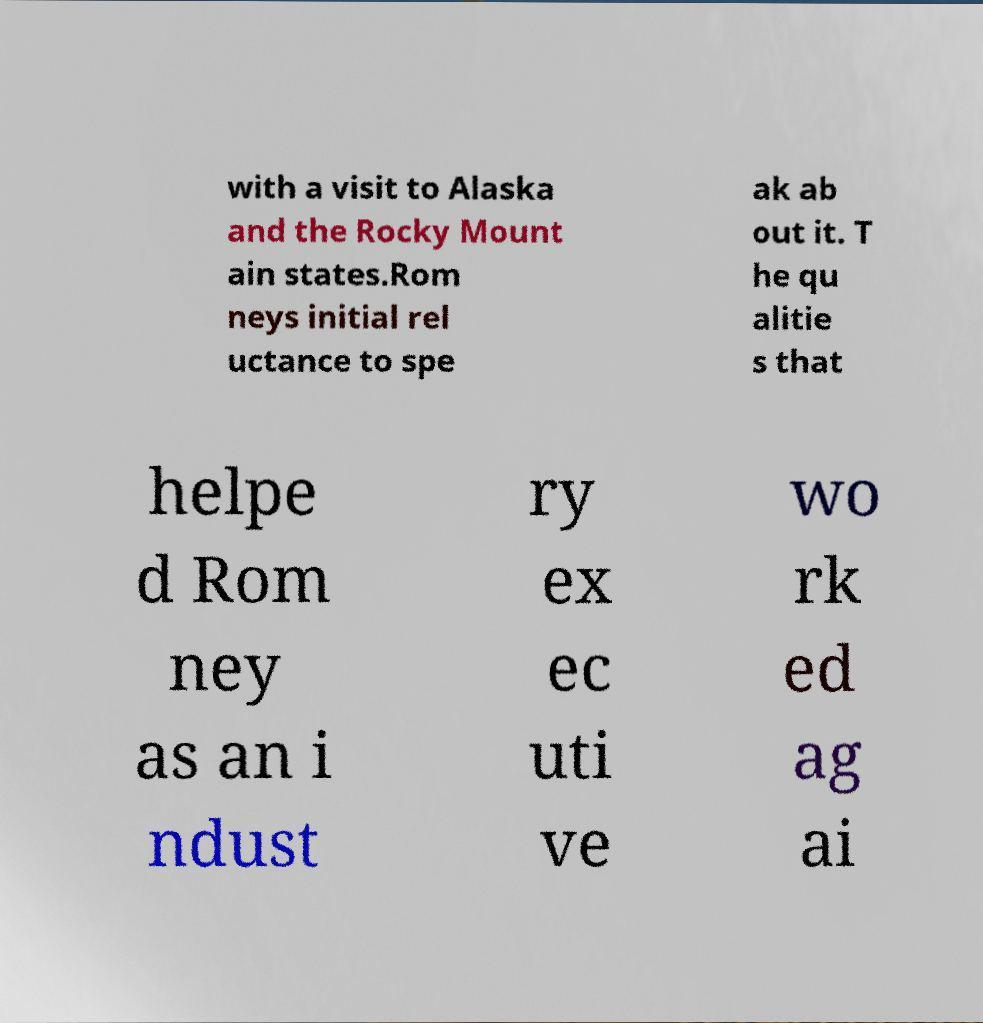Could you assist in decoding the text presented in this image and type it out clearly? with a visit to Alaska and the Rocky Mount ain states.Rom neys initial rel uctance to spe ak ab out it. T he qu alitie s that helpe d Rom ney as an i ndust ry ex ec uti ve wo rk ed ag ai 